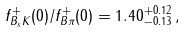Convert formula to latex. <formula><loc_0><loc_0><loc_500><loc_500>f ^ { + } _ { B _ { s } K } ( 0 ) / f ^ { + } _ { B \pi } ( 0 ) = 1 . 4 0 ^ { + 0 . 1 2 } _ { - 0 . 1 3 } \, ,</formula> 